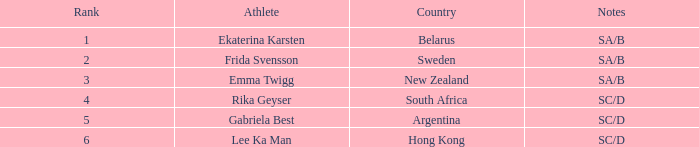What is the total rank for the athlete that had a race time of 7:34.24? 1.0. 